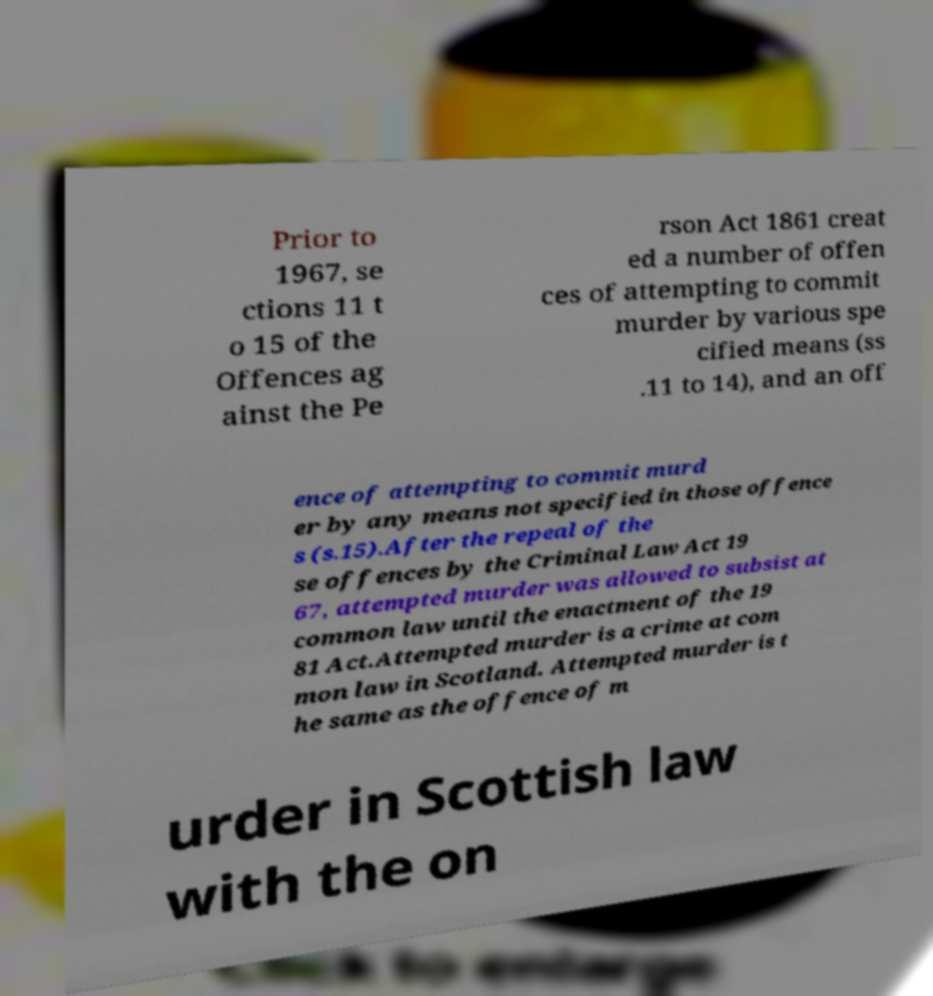Can you accurately transcribe the text from the provided image for me? Prior to 1967, se ctions 11 t o 15 of the Offences ag ainst the Pe rson Act 1861 creat ed a number of offen ces of attempting to commit murder by various spe cified means (ss .11 to 14), and an off ence of attempting to commit murd er by any means not specified in those offence s (s.15).After the repeal of the se offences by the Criminal Law Act 19 67, attempted murder was allowed to subsist at common law until the enactment of the 19 81 Act.Attempted murder is a crime at com mon law in Scotland. Attempted murder is t he same as the offence of m urder in Scottish law with the on 